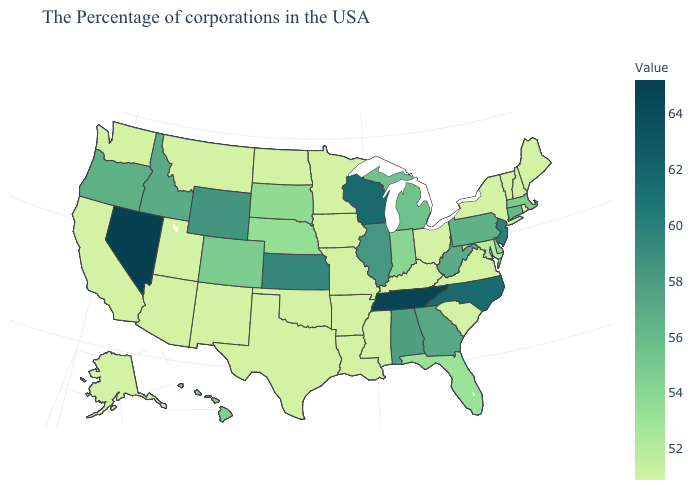Which states have the lowest value in the South?
Be succinct. Virginia, South Carolina, Kentucky, Mississippi, Louisiana, Arkansas, Oklahoma, Texas. Does the map have missing data?
Write a very short answer. No. Is the legend a continuous bar?
Concise answer only. Yes. Which states have the lowest value in the USA?
Answer briefly. Maine, Rhode Island, New Hampshire, Vermont, New York, Virginia, South Carolina, Ohio, Kentucky, Mississippi, Louisiana, Missouri, Arkansas, Minnesota, Iowa, Oklahoma, Texas, North Dakota, New Mexico, Utah, Montana, Arizona, California, Washington, Alaska. Among the states that border Washington , does Oregon have the highest value?
Quick response, please. No. 